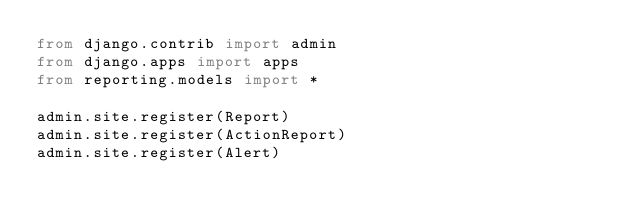Convert code to text. <code><loc_0><loc_0><loc_500><loc_500><_Python_>from django.contrib import admin
from django.apps import apps
from reporting.models import *

admin.site.register(Report)
admin.site.register(ActionReport)
admin.site.register(Alert)
</code> 